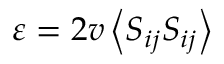<formula> <loc_0><loc_0><loc_500><loc_500>\varepsilon = 2 v \left \langle S _ { i j } S _ { i j } \right \rangle</formula> 